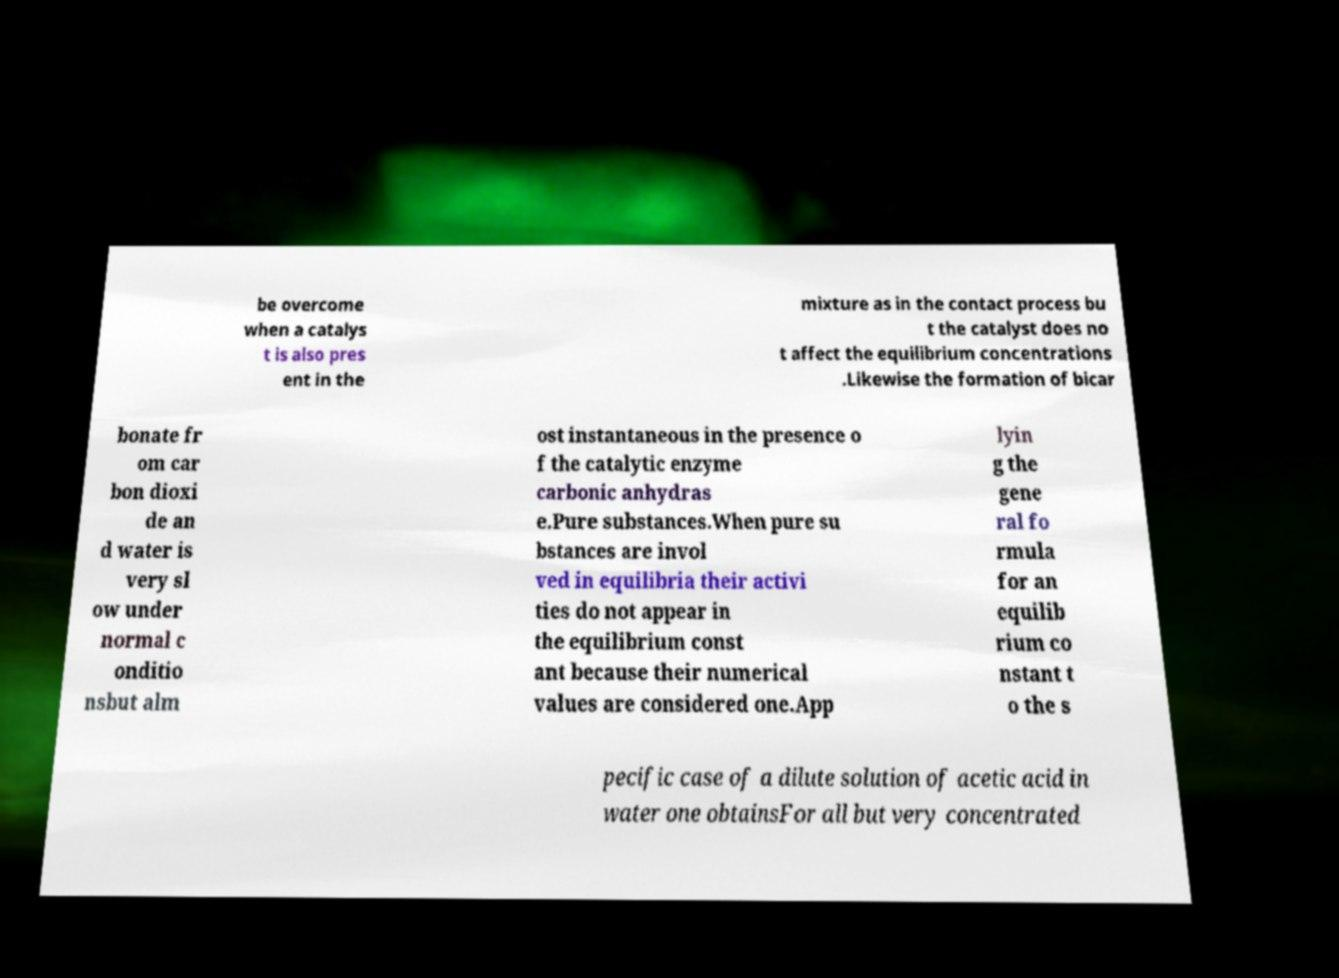Could you assist in decoding the text presented in this image and type it out clearly? be overcome when a catalys t is also pres ent in the mixture as in the contact process bu t the catalyst does no t affect the equilibrium concentrations .Likewise the formation of bicar bonate fr om car bon dioxi de an d water is very sl ow under normal c onditio nsbut alm ost instantaneous in the presence o f the catalytic enzyme carbonic anhydras e.Pure substances.When pure su bstances are invol ved in equilibria their activi ties do not appear in the equilibrium const ant because their numerical values are considered one.App lyin g the gene ral fo rmula for an equilib rium co nstant t o the s pecific case of a dilute solution of acetic acid in water one obtainsFor all but very concentrated 